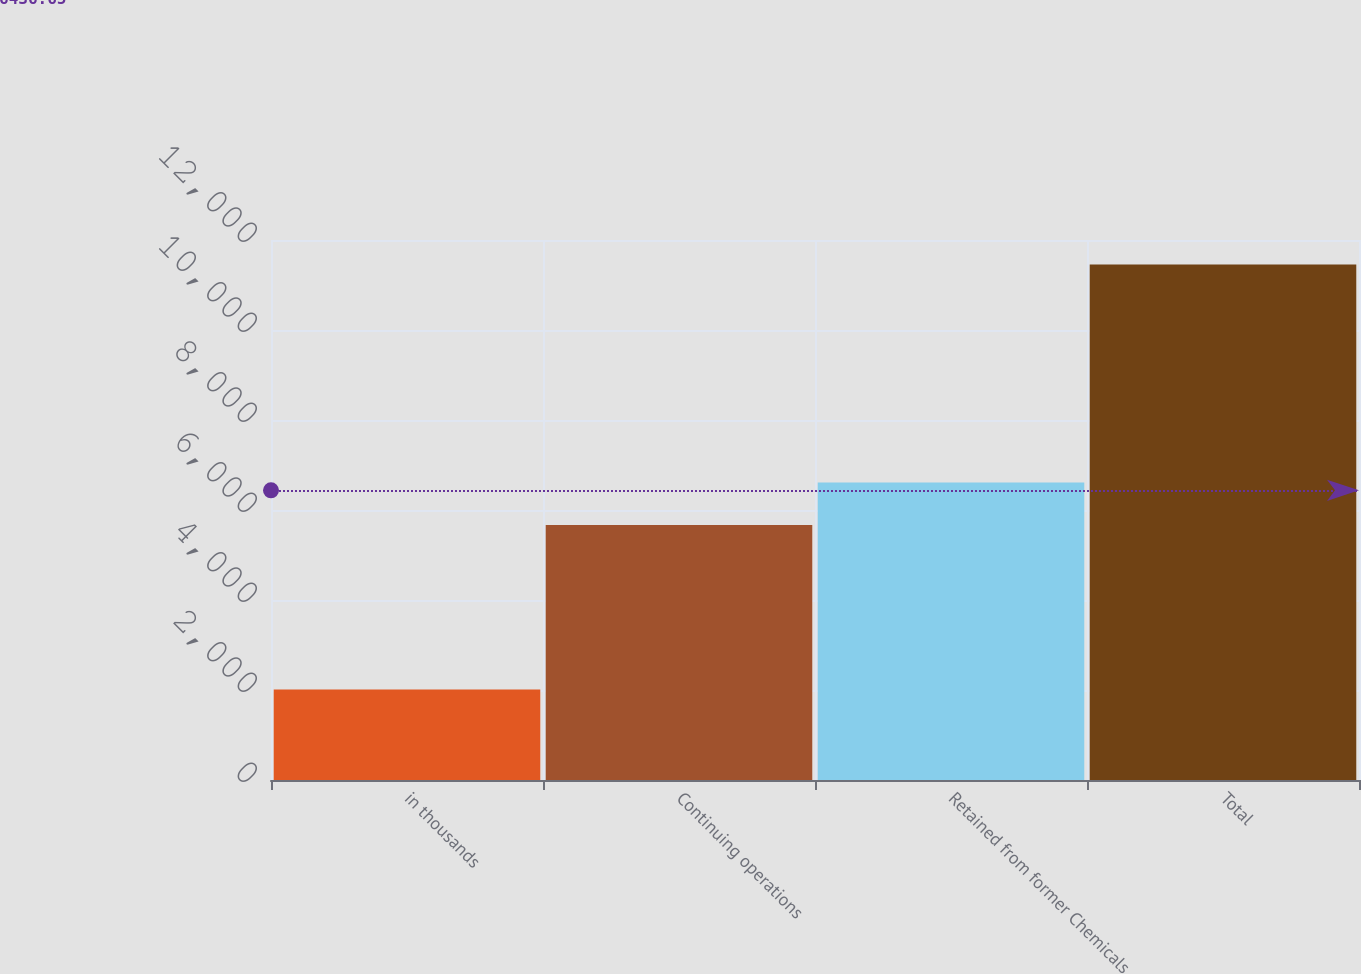Convert chart to OTSL. <chart><loc_0><loc_0><loc_500><loc_500><bar_chart><fcel>in thousands<fcel>Continuing operations<fcel>Retained from former Chemicals<fcel>Total<nl><fcel>2012<fcel>5666<fcel>6610.6<fcel>11458<nl></chart> 